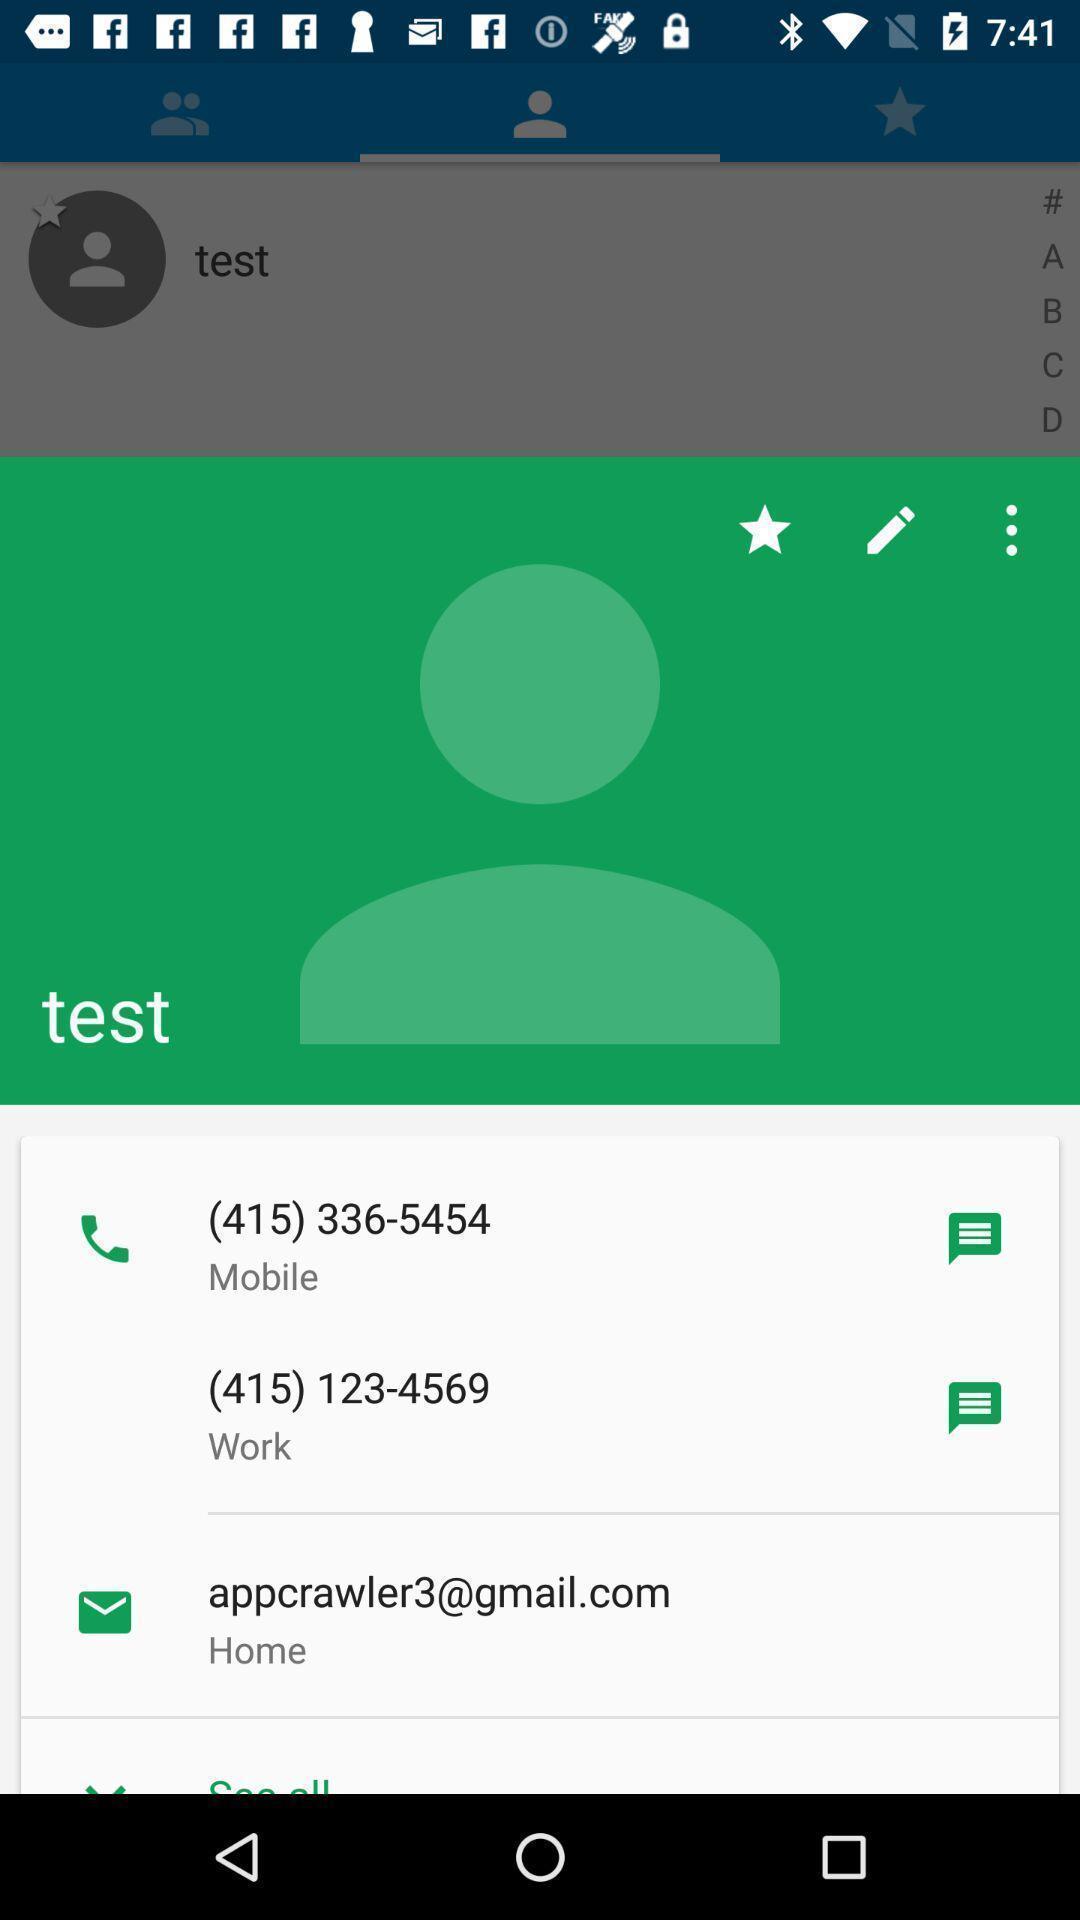Summarize the main components in this picture. Screen displaying contact info. 